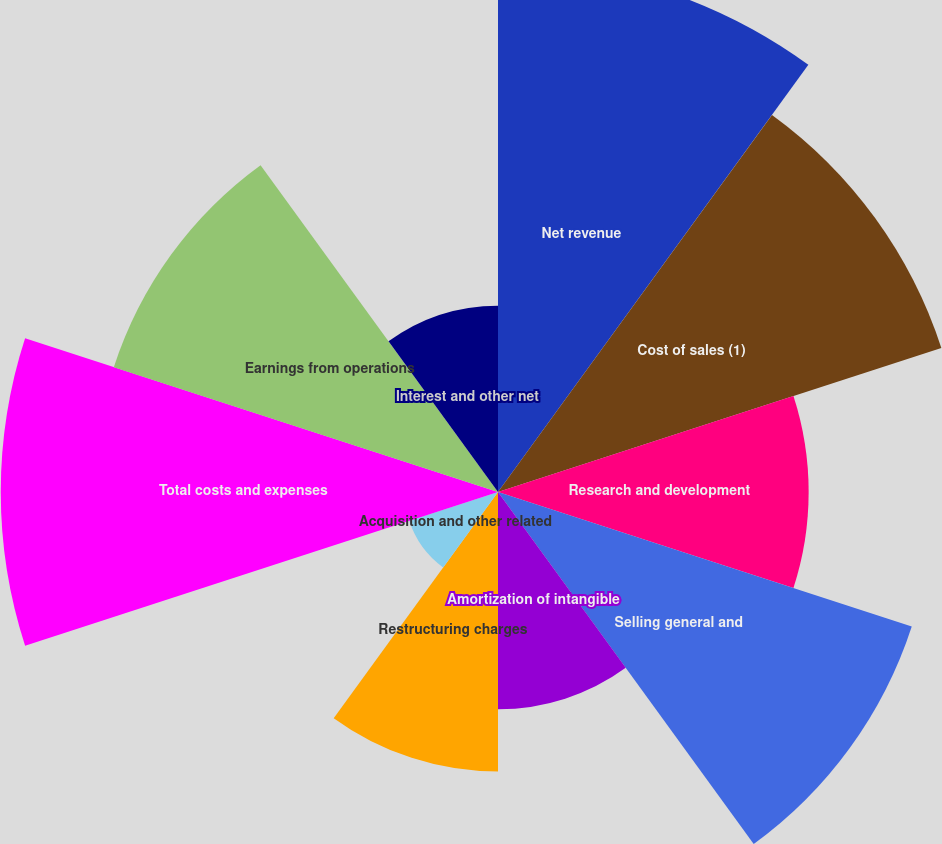<chart> <loc_0><loc_0><loc_500><loc_500><pie_chart><fcel>Net revenue<fcel>Cost of sales (1)<fcel>Research and development<fcel>Selling general and<fcel>Amortization of intangible<fcel>Restructuring charges<fcel>Acquisition and other related<fcel>Total costs and expenses<fcel>Earnings from operations<fcel>Interest and other net<nl><fcel>15.45%<fcel>13.64%<fcel>9.09%<fcel>12.73%<fcel>6.36%<fcel>8.18%<fcel>2.73%<fcel>14.55%<fcel>11.82%<fcel>5.45%<nl></chart> 